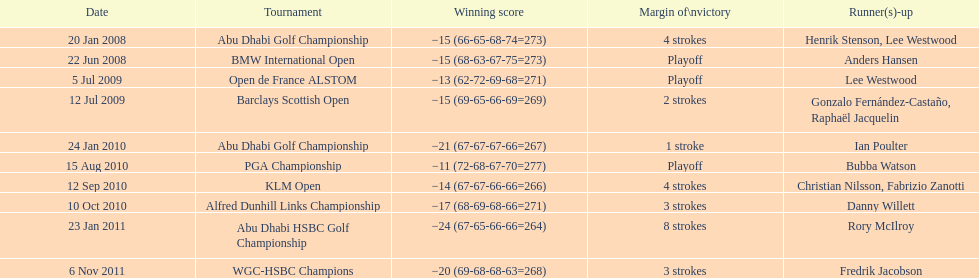How many more strokes were in the klm open than the barclays scottish open? 2 strokes. 